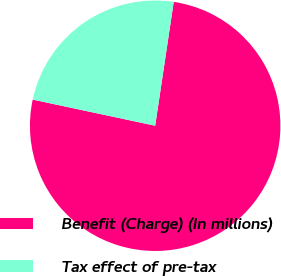<chart> <loc_0><loc_0><loc_500><loc_500><pie_chart><fcel>Benefit (Charge) (In millions)<fcel>Tax effect of pre-tax<nl><fcel>75.98%<fcel>24.02%<nl></chart> 